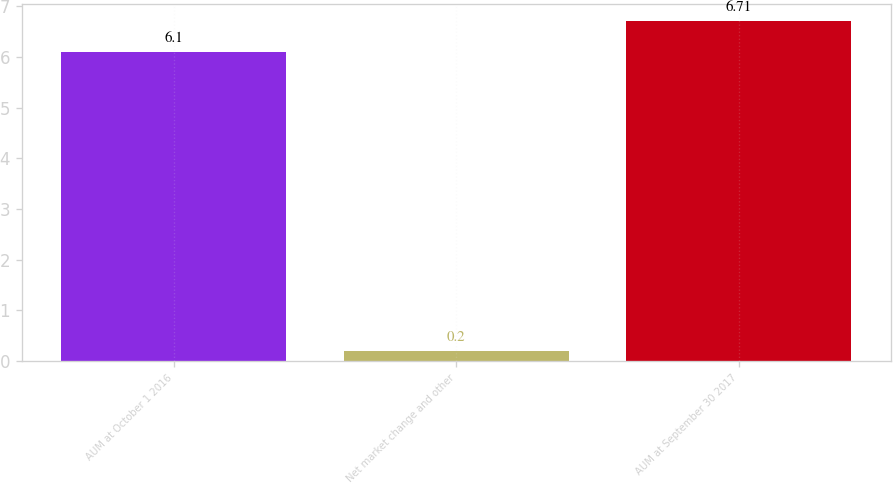Convert chart. <chart><loc_0><loc_0><loc_500><loc_500><bar_chart><fcel>AUM at October 1 2016<fcel>Net market change and other<fcel>AUM at September 30 2017<nl><fcel>6.1<fcel>0.2<fcel>6.71<nl></chart> 